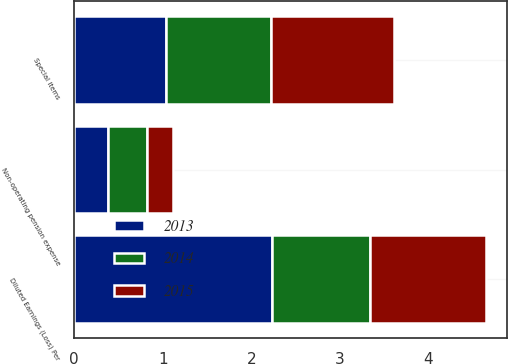Convert chart. <chart><loc_0><loc_0><loc_500><loc_500><stacked_bar_chart><ecel><fcel>Non-operating pension expense<fcel>Special items<fcel>Diluted Earnings (Loss) Per<nl><fcel>2013<fcel>0.38<fcel>1.04<fcel>2.23<nl><fcel>2015<fcel>0.3<fcel>1.39<fcel>1.31<nl><fcel>2014<fcel>0.44<fcel>1.18<fcel>1.11<nl></chart> 